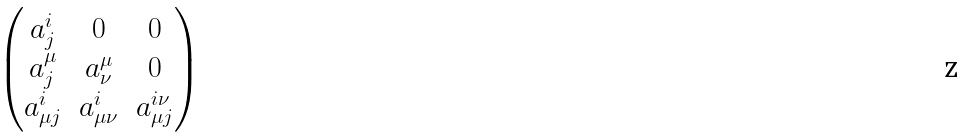Convert formula to latex. <formula><loc_0><loc_0><loc_500><loc_500>\begin{pmatrix} a ^ { i } _ { j } & 0 & 0 \\ a ^ { \mu } _ { j } & a ^ { \mu } _ { \nu } & 0 \\ a ^ { i } _ { \mu j } & a ^ { i } _ { \mu \nu } & a ^ { i \nu } _ { \mu j } \end{pmatrix}</formula> 